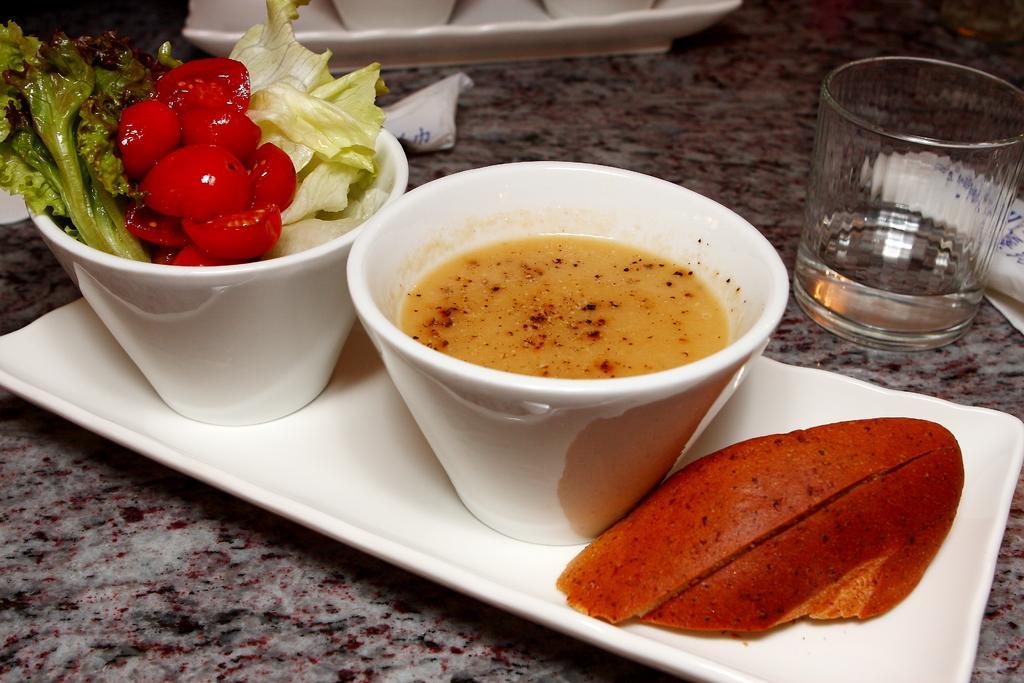In one or two sentences, can you explain what this image depicts? In this picture we can see a plate. On this plate, we can see some food items,liquid and a few things in the bowls. We can see a food item on the plate. We can see liquid in a glass. There are other objects. 